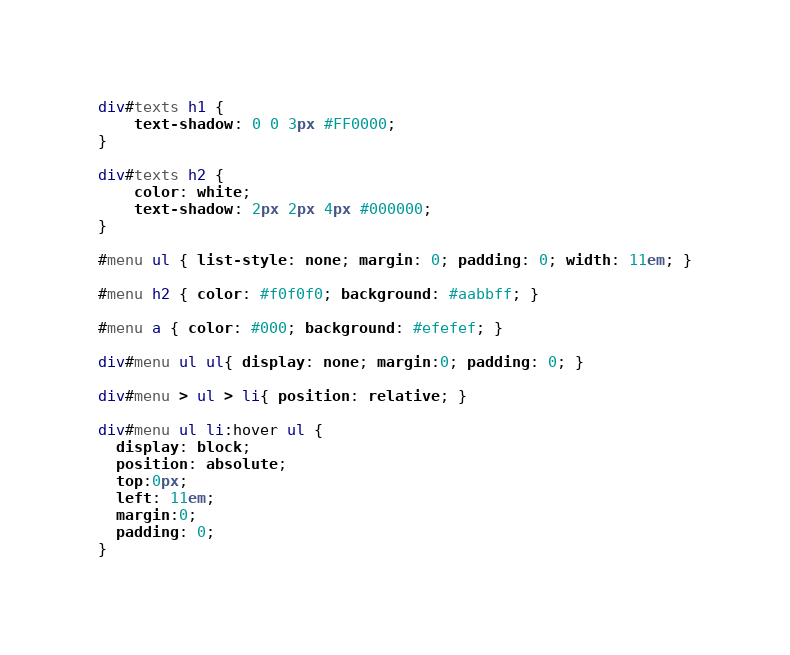Convert code to text. <code><loc_0><loc_0><loc_500><loc_500><_CSS_>div#texts h1 {
    text-shadow: 0 0 3px #FF0000;
}

div#texts h2 {
    color: white;
    text-shadow: 2px 2px 4px #000000;
}

#menu ul { list-style: none; margin: 0; padding: 0; width: 11em; }

#menu h2 { color: #f0f0f0; background: #aabbff; }

#menu a { color: #000; background: #efefef; }

div#menu ul ul{ display: none; margin:0; padding: 0; }

div#menu > ul > li{ position: relative; }

div#menu ul li:hover ul {
  display: block;
  position: absolute;
  top:0px;
  left: 11em;
  margin:0;
  padding: 0;
}
</code> 